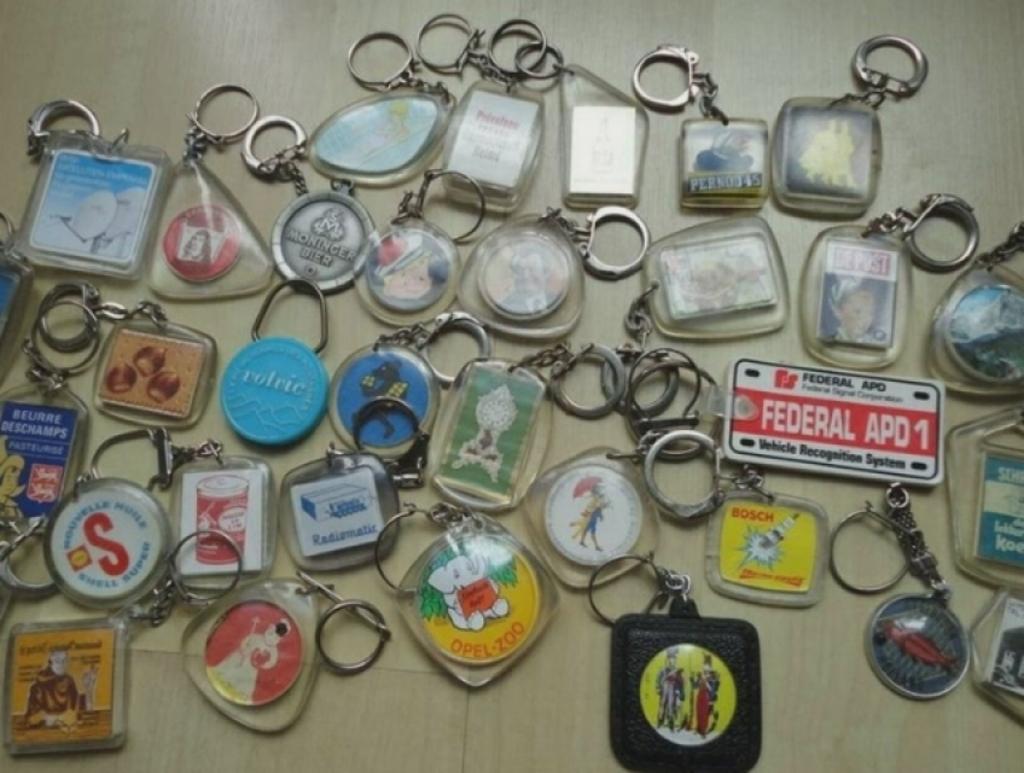Can you describe this image briefly? In this picture we can observe different shapes of keychains placed on the cream color surface. We can observe square, rectangular, triangular and circular shapes in this picture. 